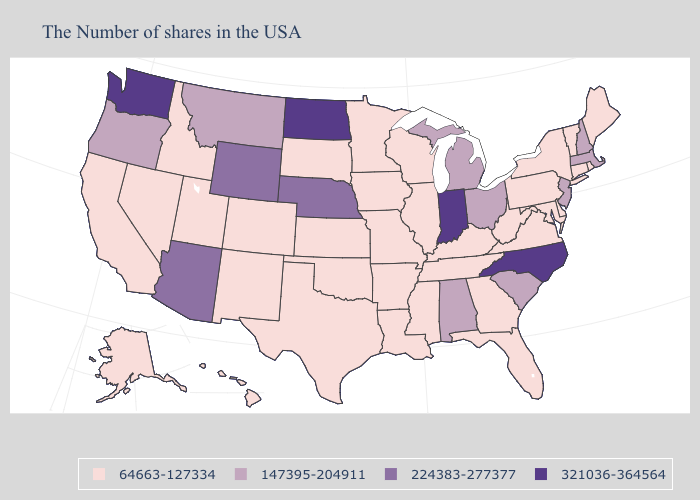Does the map have missing data?
Be succinct. No. What is the value of Indiana?
Write a very short answer. 321036-364564. What is the highest value in states that border Arkansas?
Answer briefly. 64663-127334. Name the states that have a value in the range 147395-204911?
Quick response, please. Massachusetts, New Hampshire, New Jersey, South Carolina, Ohio, Michigan, Alabama, Montana, Oregon. Among the states that border Connecticut , does Rhode Island have the lowest value?
Concise answer only. Yes. Name the states that have a value in the range 321036-364564?
Concise answer only. North Carolina, Indiana, North Dakota, Washington. Name the states that have a value in the range 321036-364564?
Short answer required. North Carolina, Indiana, North Dakota, Washington. Among the states that border Connecticut , does New York have the lowest value?
Be succinct. Yes. Name the states that have a value in the range 147395-204911?
Quick response, please. Massachusetts, New Hampshire, New Jersey, South Carolina, Ohio, Michigan, Alabama, Montana, Oregon. Which states hav the highest value in the MidWest?
Concise answer only. Indiana, North Dakota. Which states have the highest value in the USA?
Give a very brief answer. North Carolina, Indiana, North Dakota, Washington. Which states have the lowest value in the USA?
Concise answer only. Maine, Rhode Island, Vermont, Connecticut, New York, Delaware, Maryland, Pennsylvania, Virginia, West Virginia, Florida, Georgia, Kentucky, Tennessee, Wisconsin, Illinois, Mississippi, Louisiana, Missouri, Arkansas, Minnesota, Iowa, Kansas, Oklahoma, Texas, South Dakota, Colorado, New Mexico, Utah, Idaho, Nevada, California, Alaska, Hawaii. Does Maryland have a higher value than North Dakota?
Concise answer only. No. What is the highest value in states that border New York?
Short answer required. 147395-204911. Name the states that have a value in the range 224383-277377?
Be succinct. Nebraska, Wyoming, Arizona. 